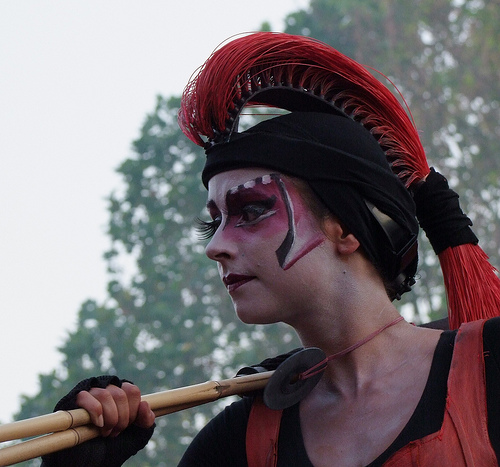<image>
Is the person next to the tree? Yes. The person is positioned adjacent to the tree, located nearby in the same general area. 